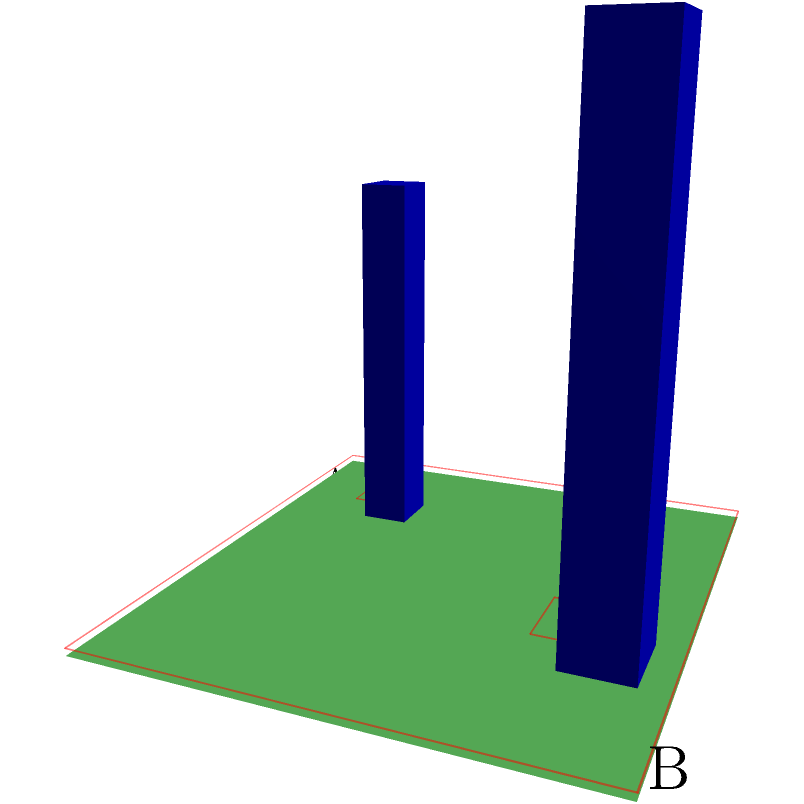In the 3D terrain shown above, you need to design a navigation mesh for pathfinding between points A and B, avoiding the blue obstacles. Which of the following statements about the red navigation mesh is correct?

a) The mesh accurately represents walkable areas and obstacle boundaries
b) The mesh needs additional polygons to represent the terrain more precisely
c) The mesh should be simplified by removing the polygons around obstacles
d) The mesh is not suitable for pathfinding in this terrain To analyze the navigation mesh for the given 3D terrain:

1. Observe the terrain: It's a flat 5x5 square with two cubic obstacles.

2. Examine the red navigation mesh:
   - It covers the entire ground area.
   - It has cutouts around the obstacles.

3. Evaluate the mesh properties:
   - The main ground area is represented by a single large polygon.
   - Each obstacle has a corresponding cutout in the mesh.
   - The cutouts closely follow the obstacle boundaries.

4. Consider pathfinding requirements:
   - Agents need to navigate around obstacles.
   - The mesh should represent walkable areas accurately.

5. Analyze the options:
   a) This is correct. The mesh accurately represents walkable areas and obstacle boundaries.
   b) Additional polygons are not necessary as the current mesh already captures the terrain features adequately.
   c) Removing polygons around obstacles would make the mesh less accurate for pathfinding.
   d) The mesh is suitable for pathfinding as it represents both walkable areas and obstacles.

The navigation mesh effectively represents the terrain's walkable areas and obstacle boundaries, allowing for accurate pathfinding between points A and B while avoiding obstacles.
Answer: a) The mesh accurately represents walkable areas and obstacle boundaries 